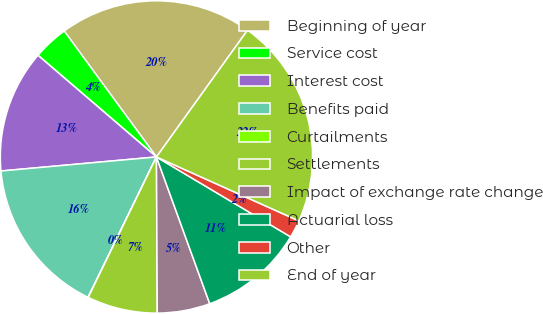<chart> <loc_0><loc_0><loc_500><loc_500><pie_chart><fcel>Beginning of year<fcel>Service cost<fcel>Interest cost<fcel>Benefits paid<fcel>Curtailments<fcel>Settlements<fcel>Impact of exchange rate change<fcel>Actuarial loss<fcel>Other<fcel>End of year<nl><fcel>19.98%<fcel>3.65%<fcel>12.72%<fcel>16.35%<fcel>0.02%<fcel>7.28%<fcel>5.46%<fcel>10.91%<fcel>1.83%<fcel>21.8%<nl></chart> 